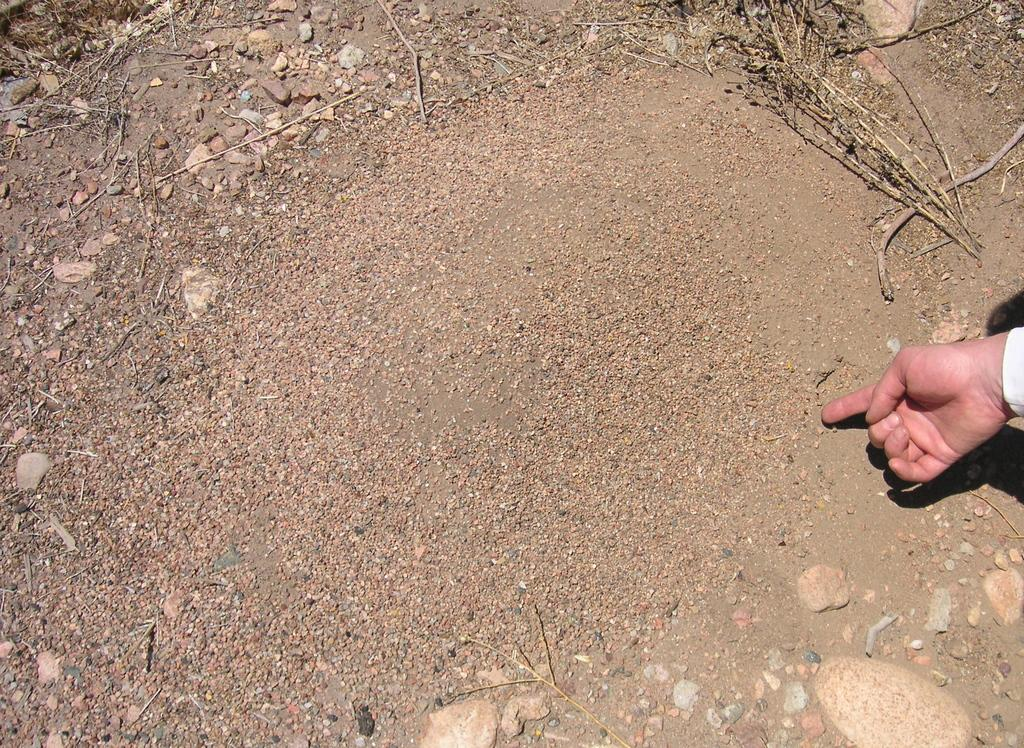Who is present in the image? There is a person in the image. What is the person wearing? The person is wearing a white shirt. What is the person doing in the image? The person is showing something on the sand surface of the ground. What other objects can be seen on the ground? There are stones and dry sticks on the ground. What arithmetic problem is the person solving on the sand surface in the image? There is no arithmetic problem visible in the image; the person is showing something on the sand surface, but it is not specified as an arithmetic problem. What type of creature can be seen interacting with the person in the image? There is no creature present in the image; only the person, the sand surface, and the objects on the ground are visible. 